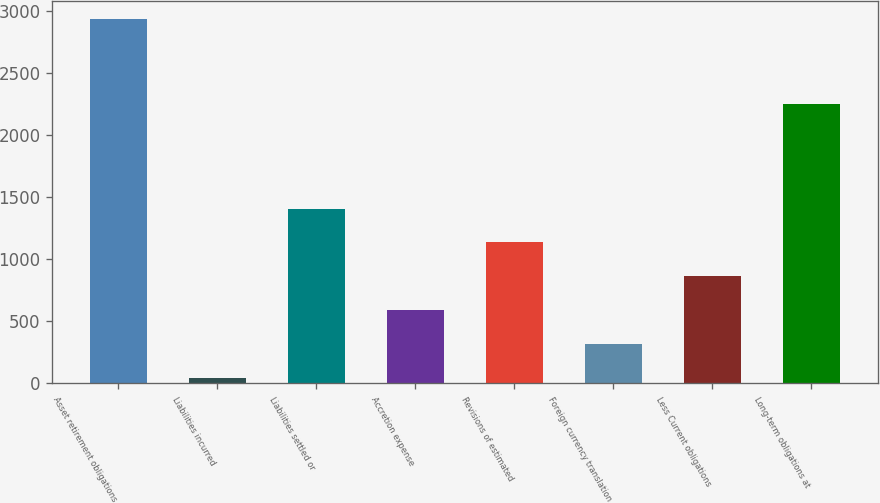Convert chart to OTSL. <chart><loc_0><loc_0><loc_500><loc_500><bar_chart><fcel>Asset retirement obligations<fcel>Liabilities incurred<fcel>Liabilities settled or<fcel>Accretion expense<fcel>Revisions of estimated<fcel>Foreign currency translation<fcel>Less Current obligations<fcel>Long-term obligations at<nl><fcel>2934<fcel>42<fcel>1407<fcel>588<fcel>1134<fcel>315<fcel>861<fcel>2249<nl></chart> 